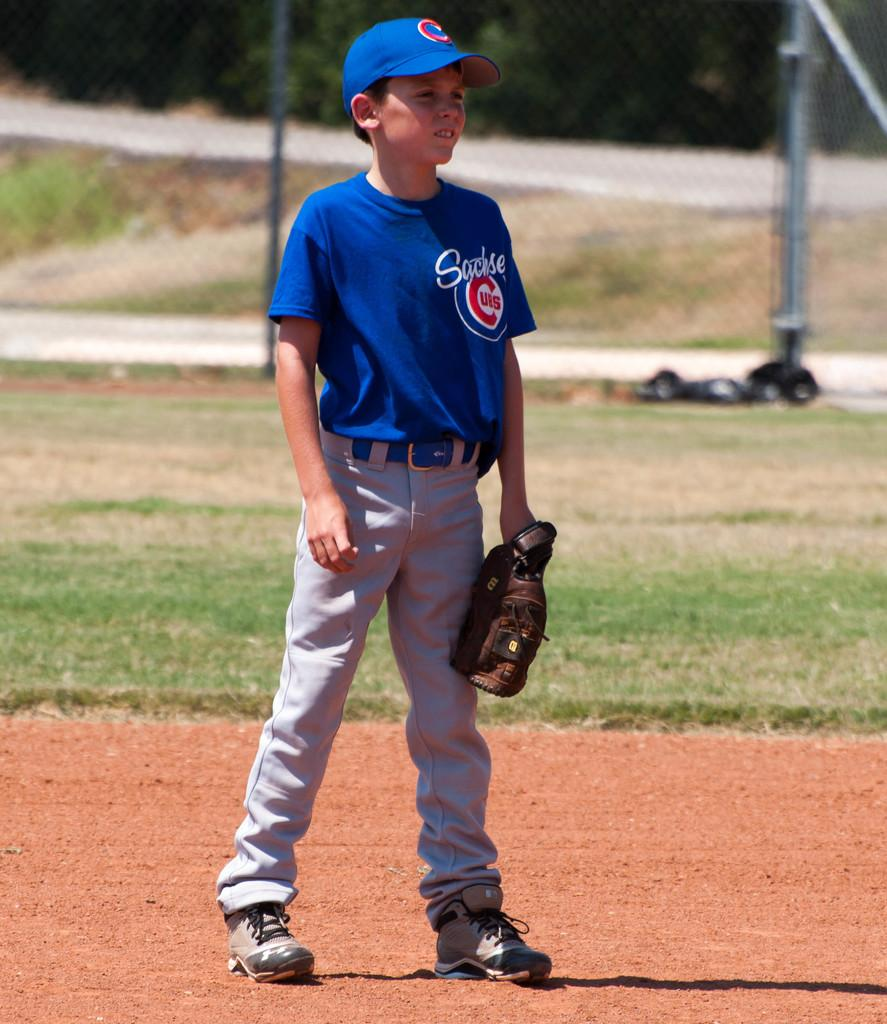<image>
Provide a brief description of the given image. A boy is on a baseball field wearing a Cubs jersey and hat. 